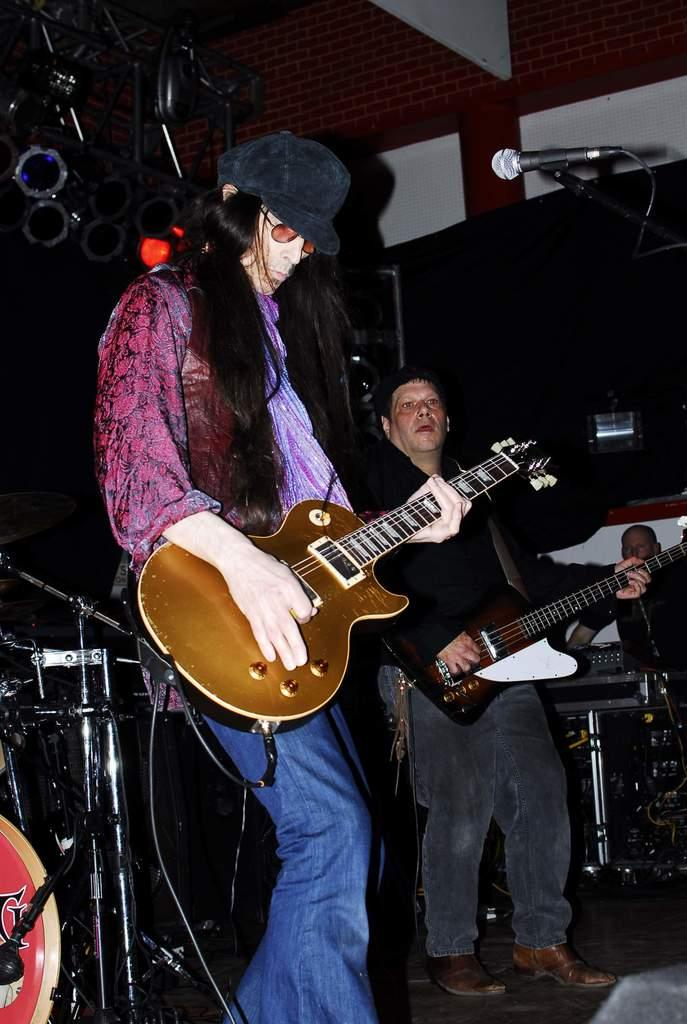How many people are in the image? There are three people in the image. What are the two men in the center doing? The two men in the center are playing guitar. What is the role of the third man standing on the side? The role of the third man standing on the side is not specified in the image. What type of pest can be seen crawling on the guitar in the image? There are no pests visible in the image, and no pests are interacting with the guitar. What type of coach is standing next to the guitar players in the image? There is no coach present in the image; only the three men are visible. 